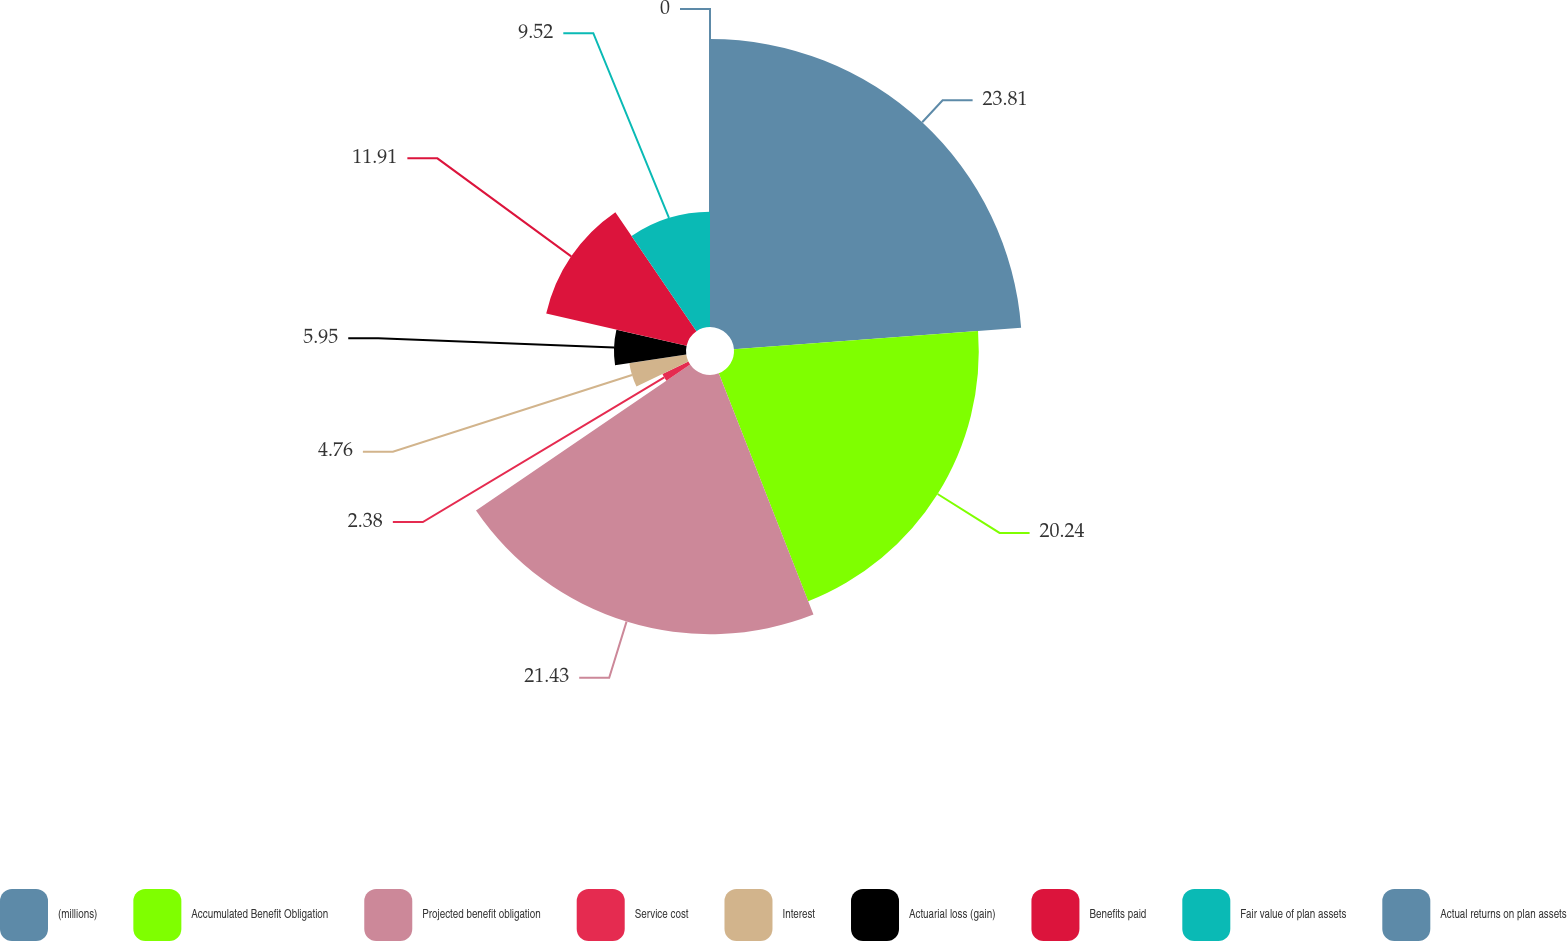Convert chart to OTSL. <chart><loc_0><loc_0><loc_500><loc_500><pie_chart><fcel>(millions)<fcel>Accumulated Benefit Obligation<fcel>Projected benefit obligation<fcel>Service cost<fcel>Interest<fcel>Actuarial loss (gain)<fcel>Benefits paid<fcel>Fair value of plan assets<fcel>Actual returns on plan assets<nl><fcel>23.8%<fcel>20.23%<fcel>21.42%<fcel>2.38%<fcel>4.76%<fcel>5.95%<fcel>11.9%<fcel>9.52%<fcel>0.0%<nl></chart> 